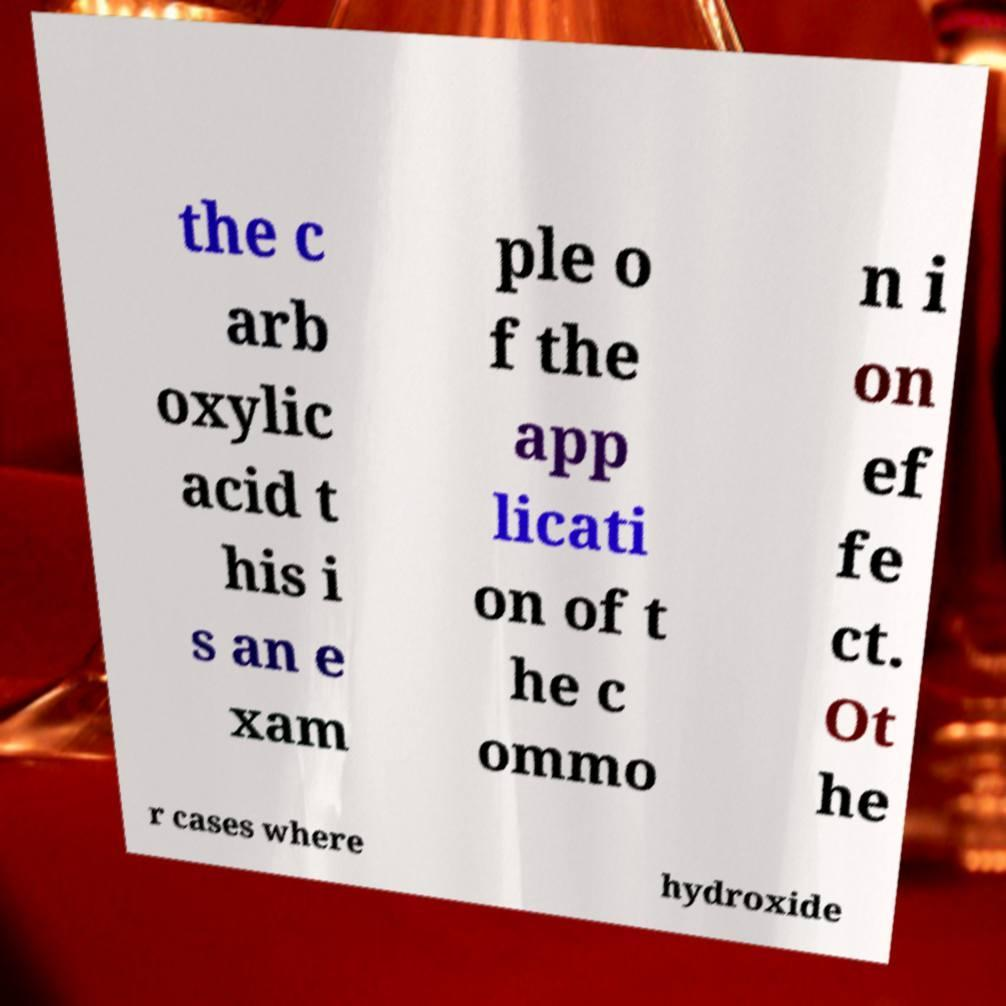Could you extract and type out the text from this image? the c arb oxylic acid t his i s an e xam ple o f the app licati on of t he c ommo n i on ef fe ct. Ot he r cases where hydroxide 